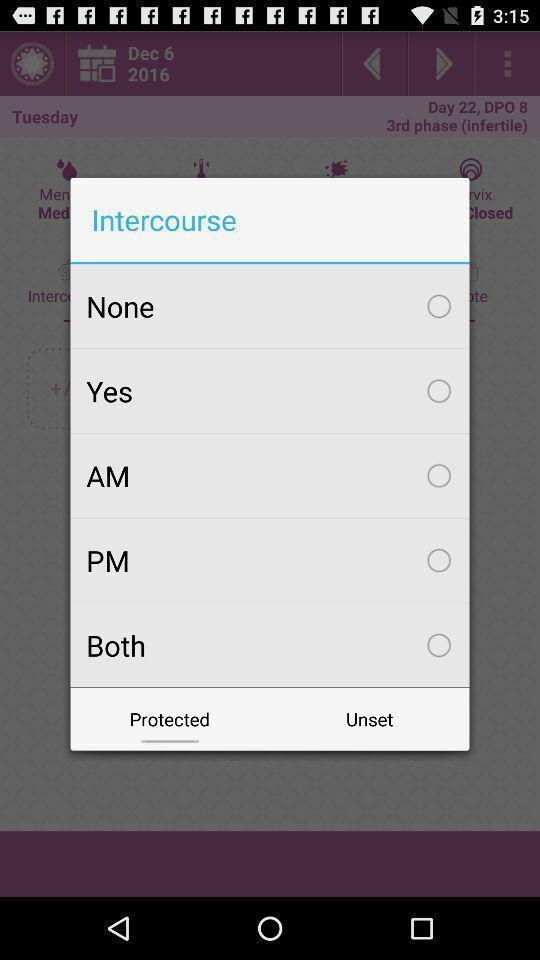Explain the elements present in this screenshot. Pop-up for the category to select. 